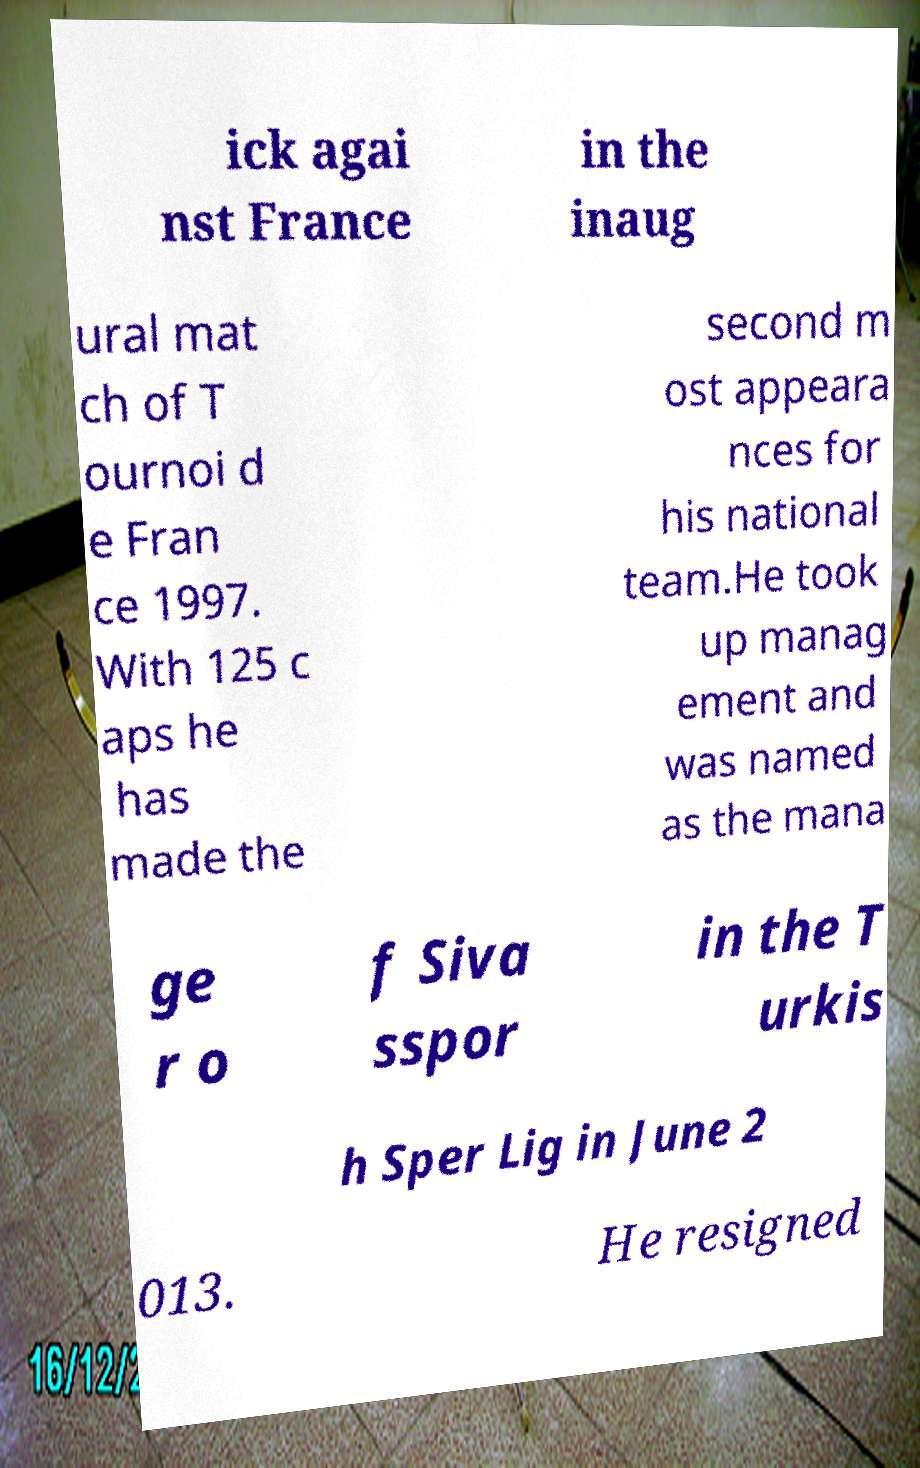For documentation purposes, I need the text within this image transcribed. Could you provide that? ick agai nst France in the inaug ural mat ch of T ournoi d e Fran ce 1997. With 125 c aps he has made the second m ost appeara nces for his national team.He took up manag ement and was named as the mana ge r o f Siva sspor in the T urkis h Sper Lig in June 2 013. He resigned 